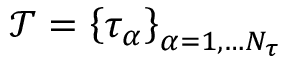Convert formula to latex. <formula><loc_0><loc_0><loc_500><loc_500>\mathcal { T } = \left \{ \tau _ { \alpha } \right \} _ { \alpha = 1 , \dots N _ { \tau } }</formula> 